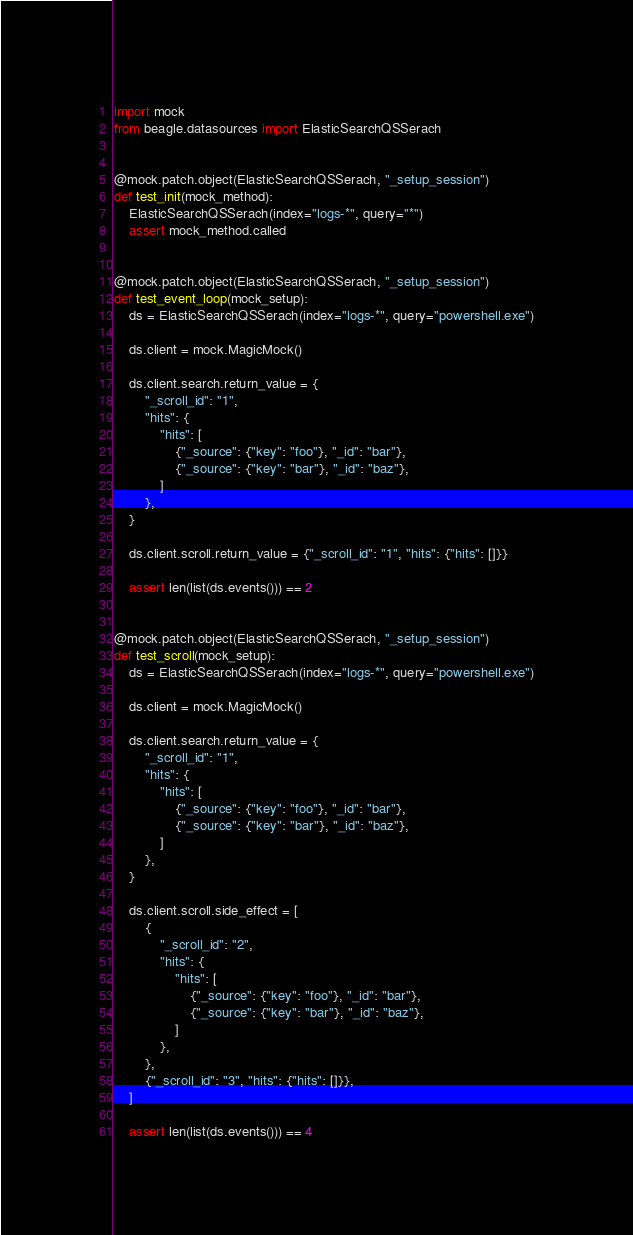Convert code to text. <code><loc_0><loc_0><loc_500><loc_500><_Python_>import mock
from beagle.datasources import ElasticSearchQSSerach


@mock.patch.object(ElasticSearchQSSerach, "_setup_session")
def test_init(mock_method):
    ElasticSearchQSSerach(index="logs-*", query="*")
    assert mock_method.called


@mock.patch.object(ElasticSearchQSSerach, "_setup_session")
def test_event_loop(mock_setup):
    ds = ElasticSearchQSSerach(index="logs-*", query="powershell.exe")

    ds.client = mock.MagicMock()

    ds.client.search.return_value = {
        "_scroll_id": "1",
        "hits": {
            "hits": [
                {"_source": {"key": "foo"}, "_id": "bar"},
                {"_source": {"key": "bar"}, "_id": "baz"},
            ]
        },
    }

    ds.client.scroll.return_value = {"_scroll_id": "1", "hits": {"hits": []}}

    assert len(list(ds.events())) == 2


@mock.patch.object(ElasticSearchQSSerach, "_setup_session")
def test_scroll(mock_setup):
    ds = ElasticSearchQSSerach(index="logs-*", query="powershell.exe")

    ds.client = mock.MagicMock()

    ds.client.search.return_value = {
        "_scroll_id": "1",
        "hits": {
            "hits": [
                {"_source": {"key": "foo"}, "_id": "bar"},
                {"_source": {"key": "bar"}, "_id": "baz"},
            ]
        },
    }

    ds.client.scroll.side_effect = [
        {
            "_scroll_id": "2",
            "hits": {
                "hits": [
                    {"_source": {"key": "foo"}, "_id": "bar"},
                    {"_source": {"key": "bar"}, "_id": "baz"},
                ]
            },
        },
        {"_scroll_id": "3", "hits": {"hits": []}},
    ]

    assert len(list(ds.events())) == 4
</code> 